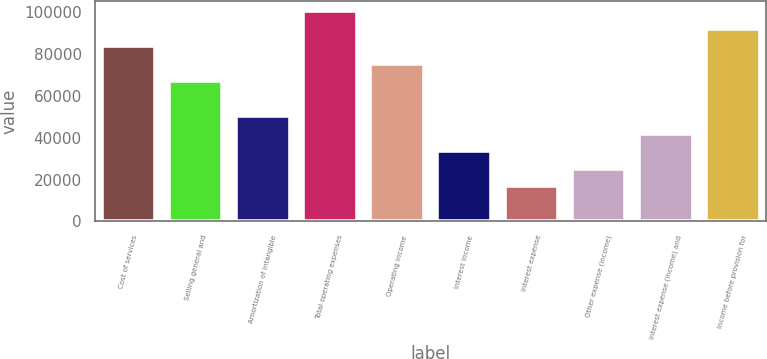Convert chart to OTSL. <chart><loc_0><loc_0><loc_500><loc_500><bar_chart><fcel>Cost of services<fcel>Selling general and<fcel>Amortization of intangible<fcel>Total operating expenses<fcel>Operating income<fcel>Interest income<fcel>Interest expense<fcel>Other expense (income)<fcel>Interest expense (income) and<fcel>Income before provision for<nl><fcel>83900<fcel>67120<fcel>50340.1<fcel>100680<fcel>75510<fcel>33560.1<fcel>16780.2<fcel>25170.2<fcel>41950.1<fcel>92289.9<nl></chart> 